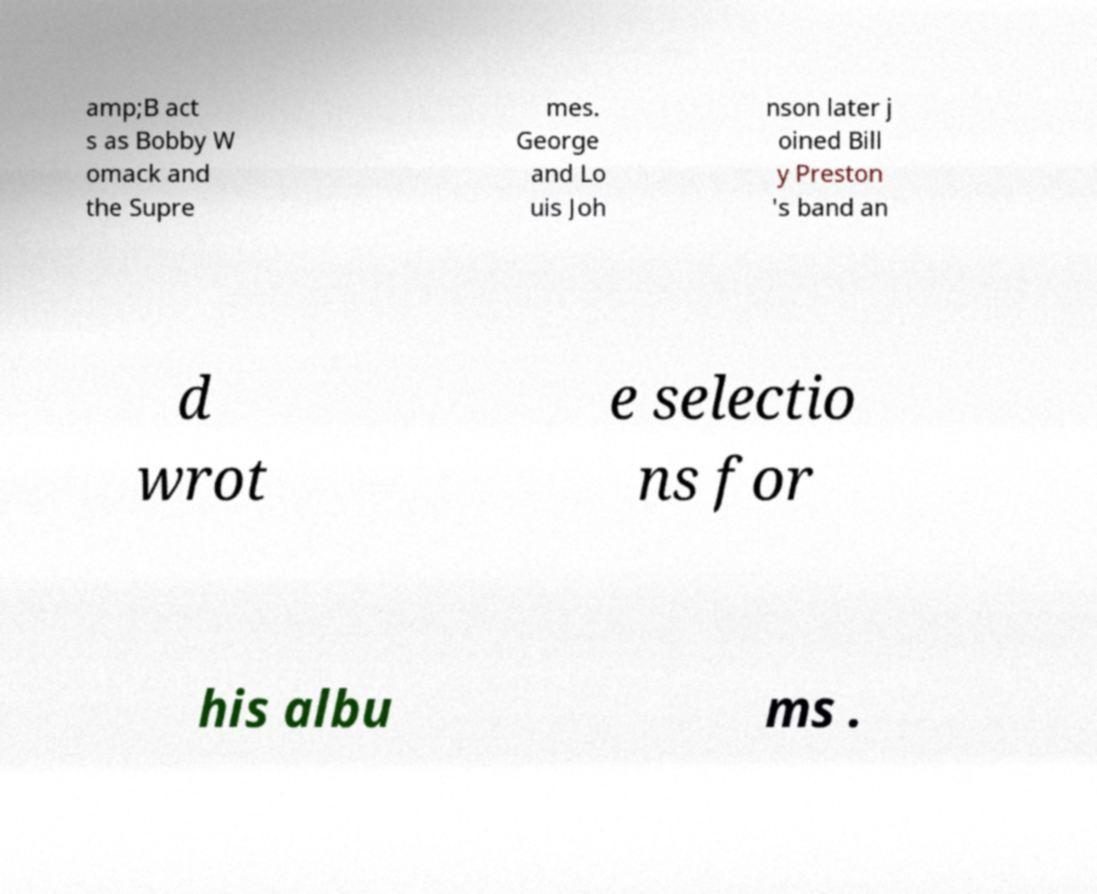Can you read and provide the text displayed in the image?This photo seems to have some interesting text. Can you extract and type it out for me? amp;B act s as Bobby W omack and the Supre mes. George and Lo uis Joh nson later j oined Bill y Preston 's band an d wrot e selectio ns for his albu ms . 